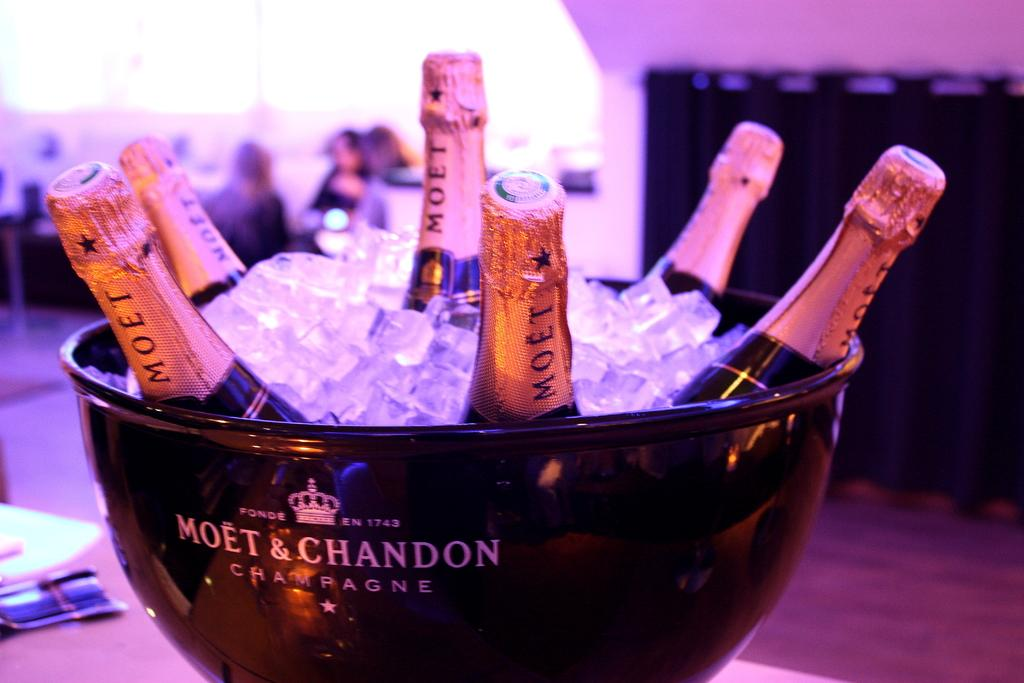<image>
Create a compact narrative representing the image presented. A bucket that says Moet & Chandon full of ice and with 6 Merlot bottles of wine in it. 